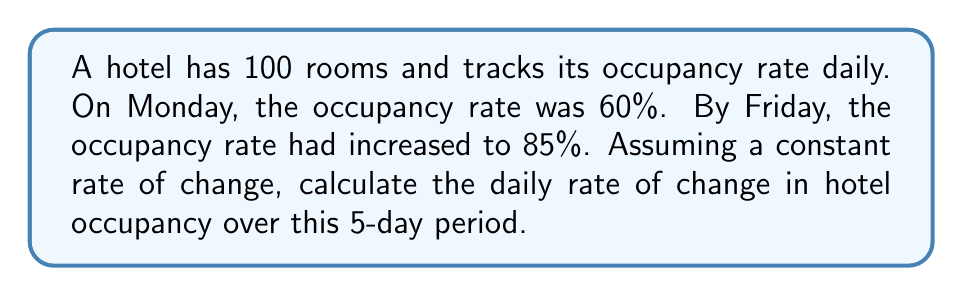Can you answer this question? Let's approach this step-by-step:

1) First, we need to identify the key information:
   - Initial occupancy rate (Monday): 60% = 0.60
   - Final occupancy rate (Friday): 85% = 0.85
   - Time period: 5 days

2) The rate of change is given by the formula:

   $$\text{Rate of change} = \frac{\text{Change in occupancy}}{\text{Change in time}}$$

3) Calculate the change in occupancy:
   $$\text{Change in occupancy} = 0.85 - 0.60 = 0.25$$

4) The change in time is 5 days.

5) Now, let's apply the formula:

   $$\text{Rate of change} = \frac{0.25}{5} = 0.05$$

6) This means the occupancy rate increased by 0.05 or 5% each day.

7) To express this as a percentage per day:
   $$0.05 \times 100\% = 5\% \text{ per day}$$
Answer: 5% per day 